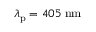<formula> <loc_0><loc_0><loc_500><loc_500>\lambda _ { p } = 4 0 5 \, n m</formula> 